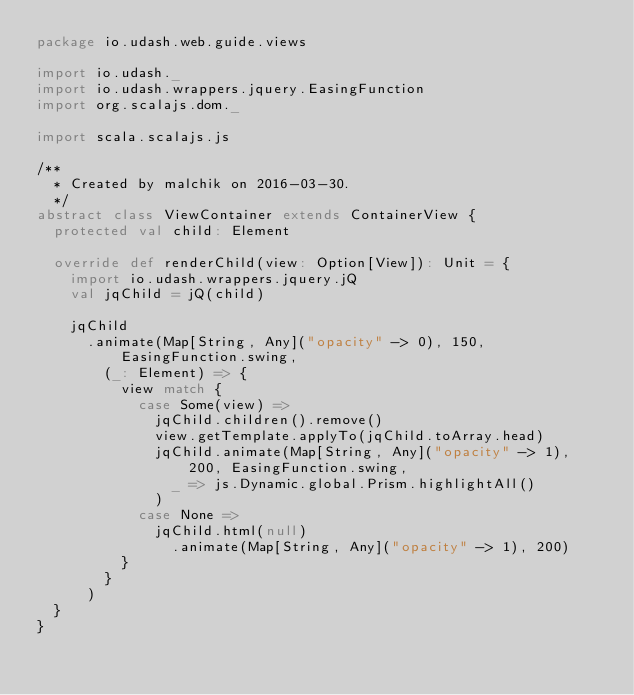<code> <loc_0><loc_0><loc_500><loc_500><_Scala_>package io.udash.web.guide.views

import io.udash._
import io.udash.wrappers.jquery.EasingFunction
import org.scalajs.dom._

import scala.scalajs.js

/**
  * Created by malchik on 2016-03-30.
  */
abstract class ViewContainer extends ContainerView {
  protected val child: Element

  override def renderChild(view: Option[View]): Unit = {
    import io.udash.wrappers.jquery.jQ
    val jqChild = jQ(child)

    jqChild
      .animate(Map[String, Any]("opacity" -> 0), 150, EasingFunction.swing,
        (_: Element) => {
          view match {
            case Some(view) =>
              jqChild.children().remove()
              view.getTemplate.applyTo(jqChild.toArray.head)
              jqChild.animate(Map[String, Any]("opacity" -> 1), 200, EasingFunction.swing,
                _ => js.Dynamic.global.Prism.highlightAll()
              )
            case None =>
              jqChild.html(null)
                .animate(Map[String, Any]("opacity" -> 1), 200)
          }
        }
      )
  }
}
</code> 